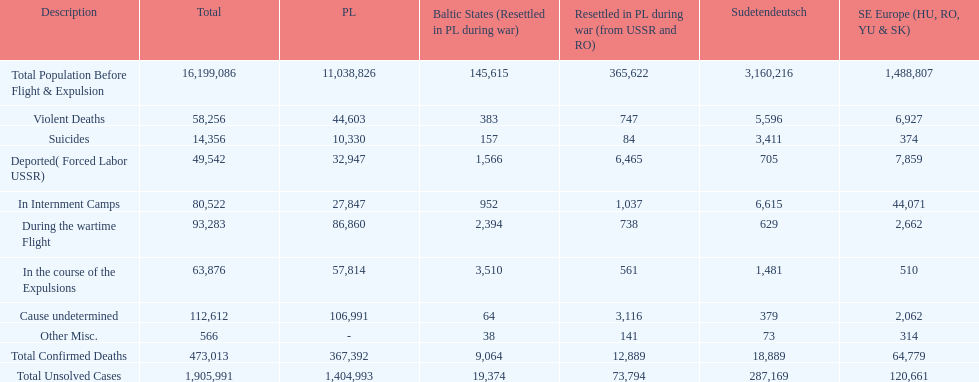Were there more cause undetermined or miscellaneous deaths in the baltic states? Cause undetermined. 